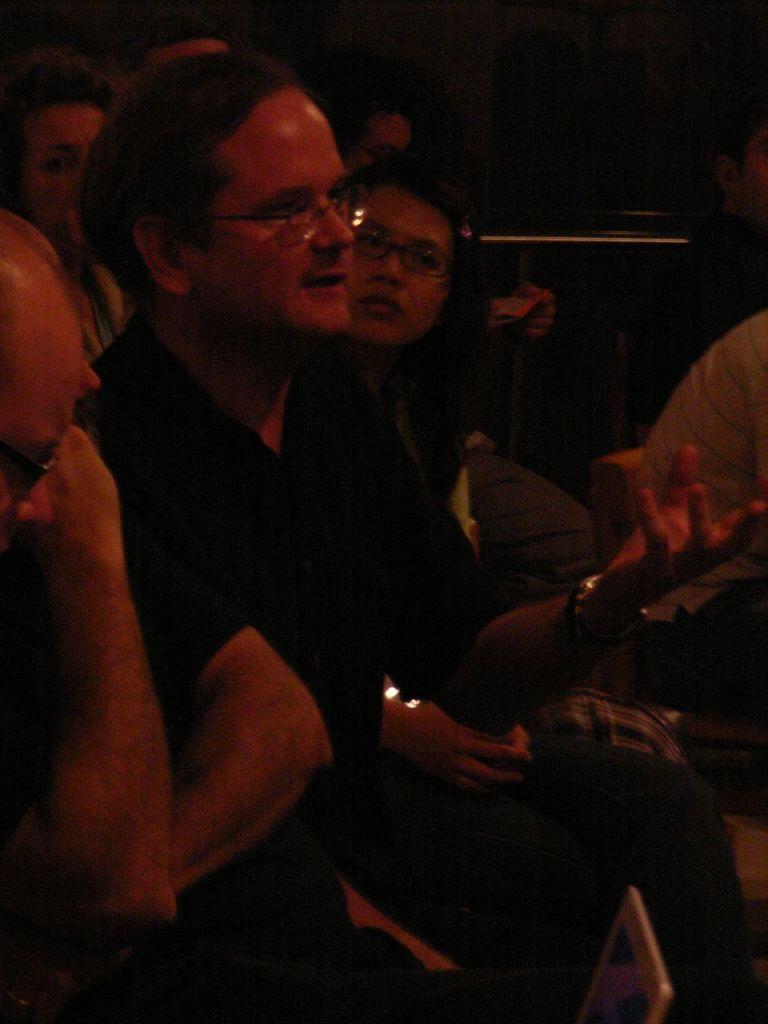Could you give a brief overview of what you see in this image? In this picture I can see few people are sitting and looks like a laptop screen at the bottom of the picture and I can see dark background. 